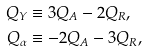Convert formula to latex. <formula><loc_0><loc_0><loc_500><loc_500>Q _ { Y } & \equiv 3 Q _ { A } - 2 Q _ { R } , \\ Q _ { \alpha } & \equiv - 2 Q _ { A } - 3 Q _ { R } ,</formula> 